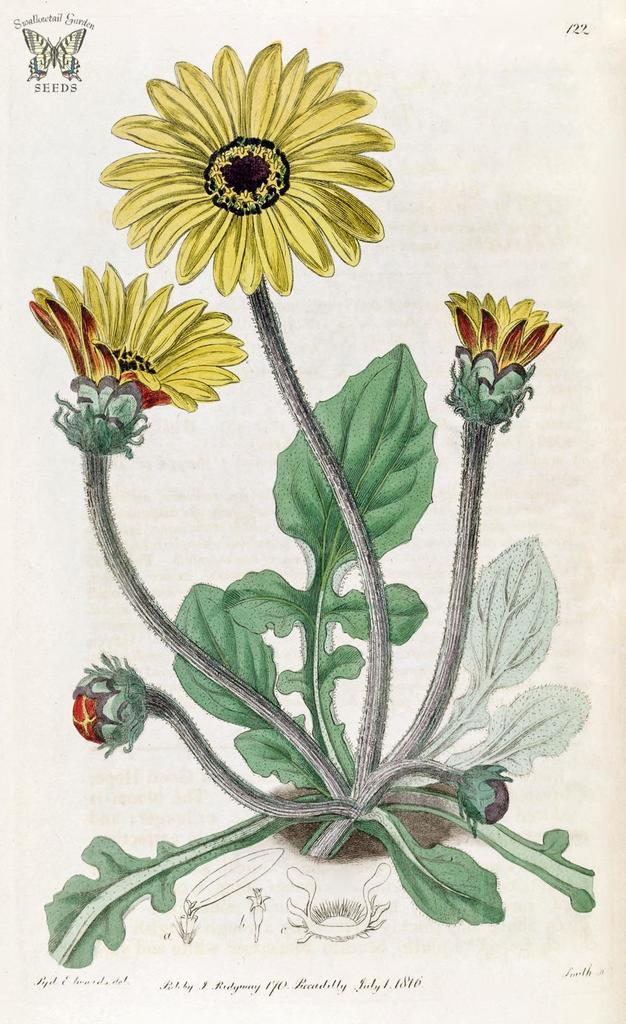What is depicted in the image? There is a drawing in the image. What is the subject of the drawing? The drawing is of a yellow lotus flower plant. What is the color of the paper on which the drawing is made? The drawing is on white paper. What type of bird can be seen flying in the image? There are no birds present in the image; it features a drawing of a yellow lotus flower plant on white paper. 